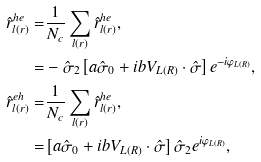<formula> <loc_0><loc_0><loc_500><loc_500>\hat { r } ^ { h e } _ { l ( r ) } = & \frac { 1 } { N _ { c } } \sum _ { l ( r ) } \hat { r } ^ { h e } _ { l ( r ) } , \\ = & - \hat { \sigma } _ { 2 } \left [ a \hat { \sigma } _ { 0 } + i b V _ { L ( R ) } \cdot \hat { \sigma } \right ] e ^ { - i \varphi _ { L ( R ) } } , \\ \hat { r } ^ { e h } _ { l ( r ) } = & \frac { 1 } { N _ { c } } \sum _ { l ( r ) } \hat { r } ^ { h e } _ { l ( r ) } , \\ = & \left [ a \hat { \sigma } _ { 0 } + i b V _ { L ( R ) } \cdot \hat { \sigma } \right ] \hat { \sigma } _ { 2 } e ^ { i \varphi _ { L ( R ) } } ,</formula> 